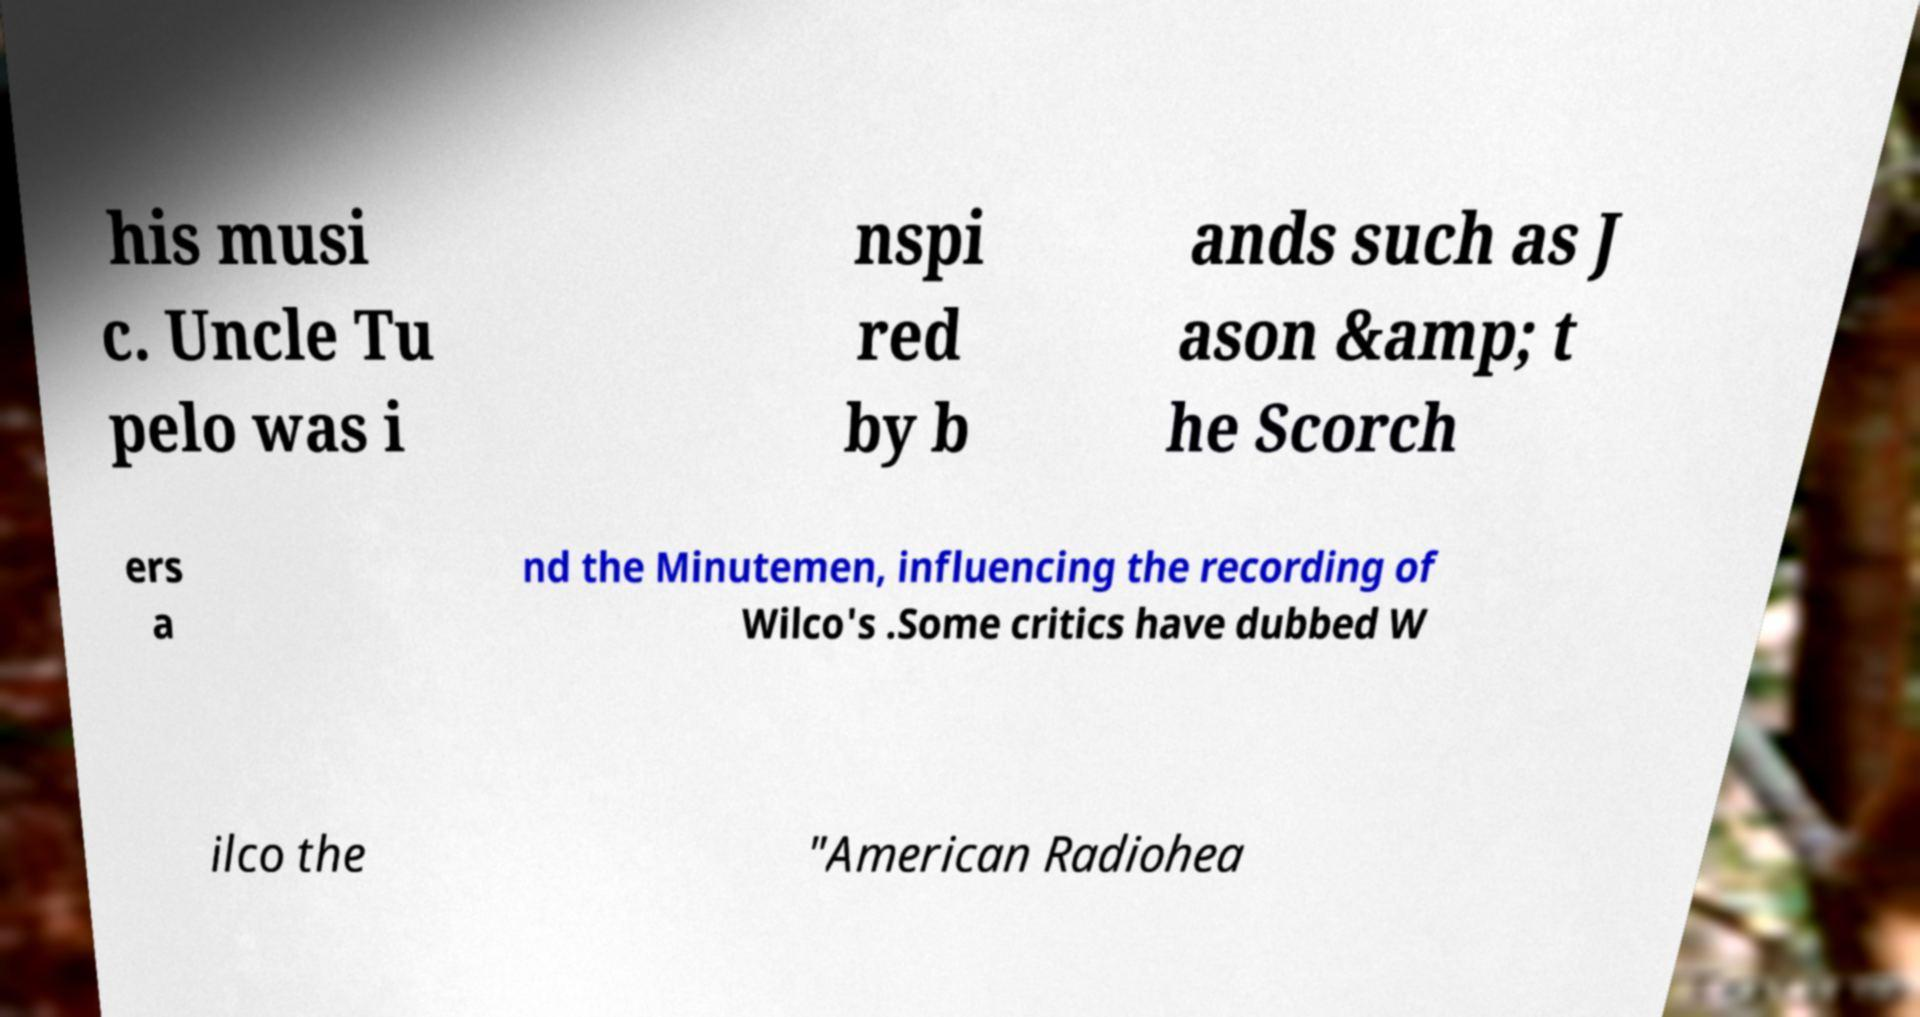What messages or text are displayed in this image? I need them in a readable, typed format. his musi c. Uncle Tu pelo was i nspi red by b ands such as J ason &amp; t he Scorch ers a nd the Minutemen, influencing the recording of Wilco's .Some critics have dubbed W ilco the "American Radiohea 